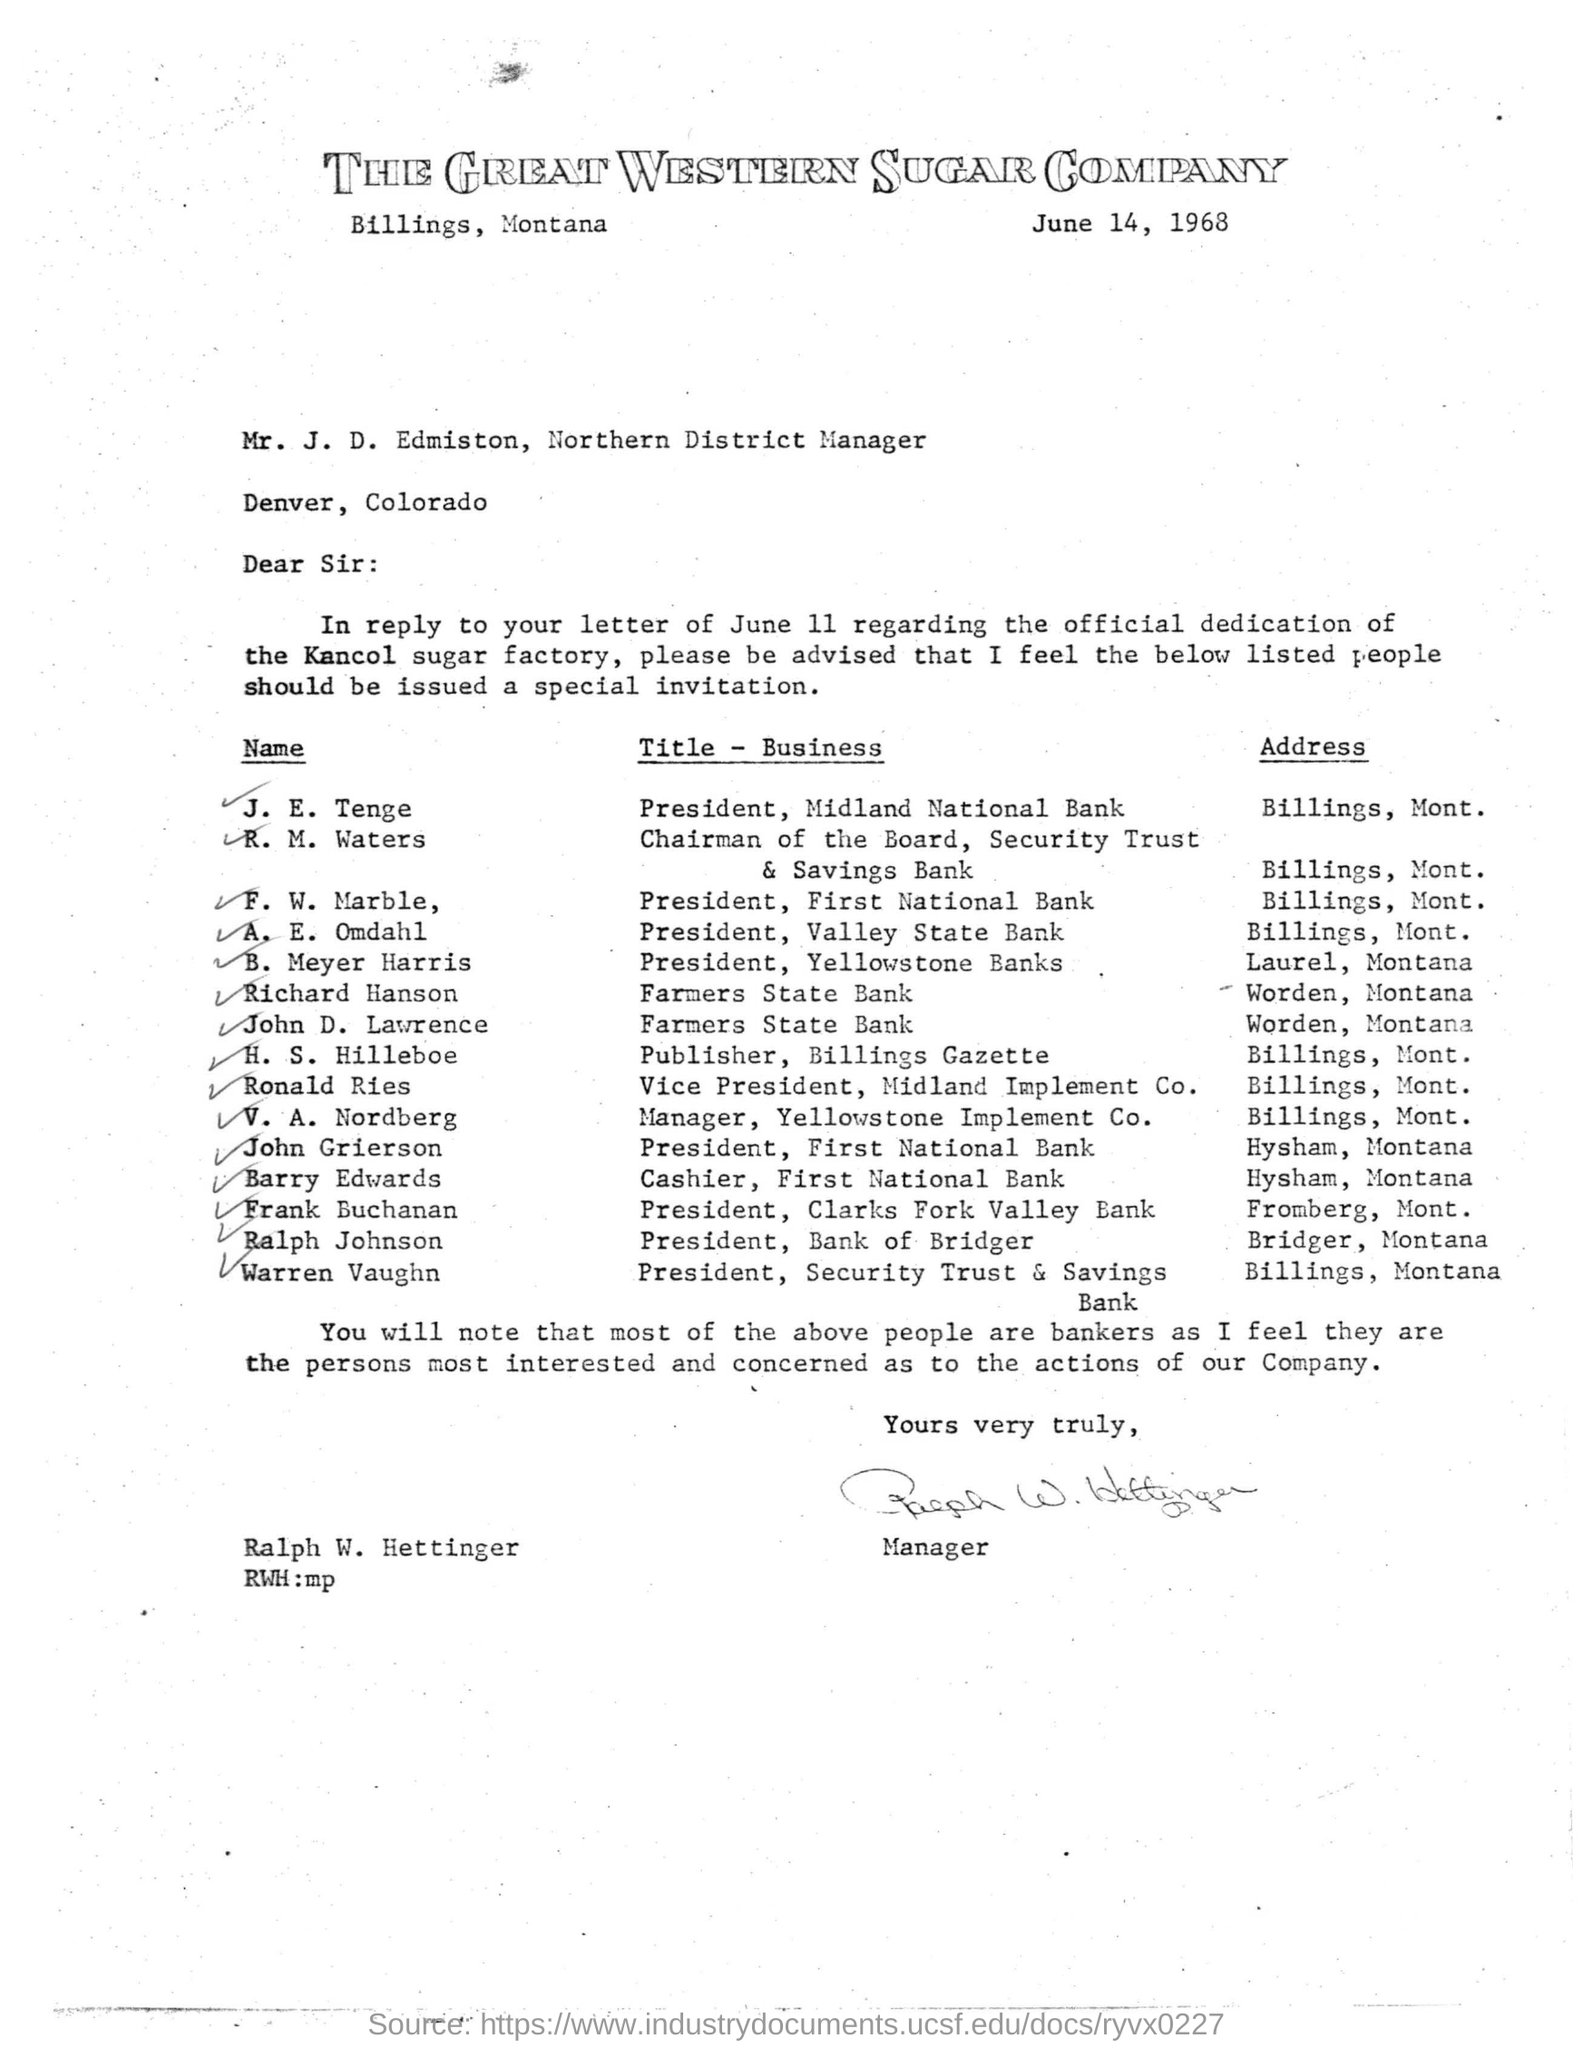Mention a couple of crucial points in this snapshot. Ralph W. Hettinger wrote the letter. F. W. Marble is the president of the First National Bank. Mr. J. D. Edmiston's designation is Northern District Manager. 